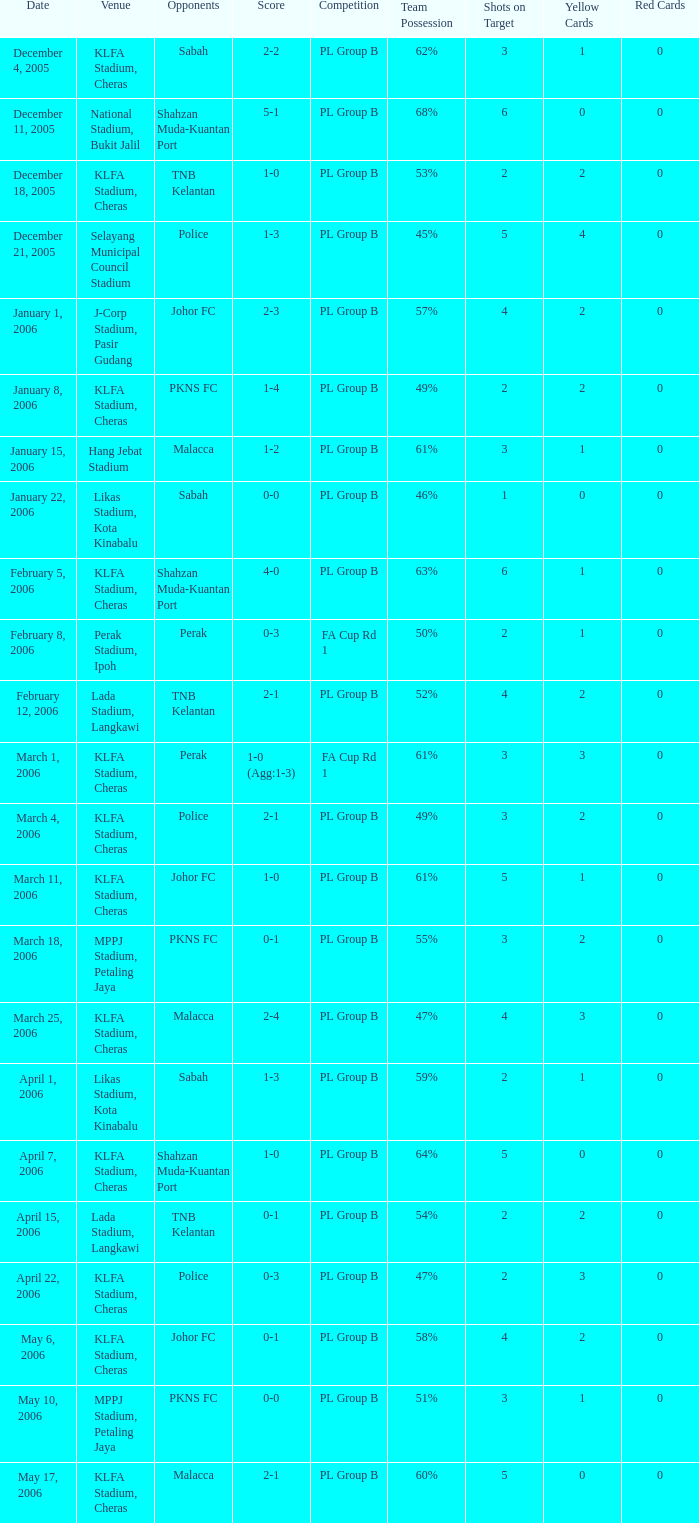Which Competition has Opponents of pkns fc, and a Score of 0-0? PL Group B. 